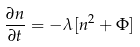<formula> <loc_0><loc_0><loc_500><loc_500>\frac { \partial n } { \partial t } = - \lambda [ n ^ { 2 } + \Phi ]</formula> 